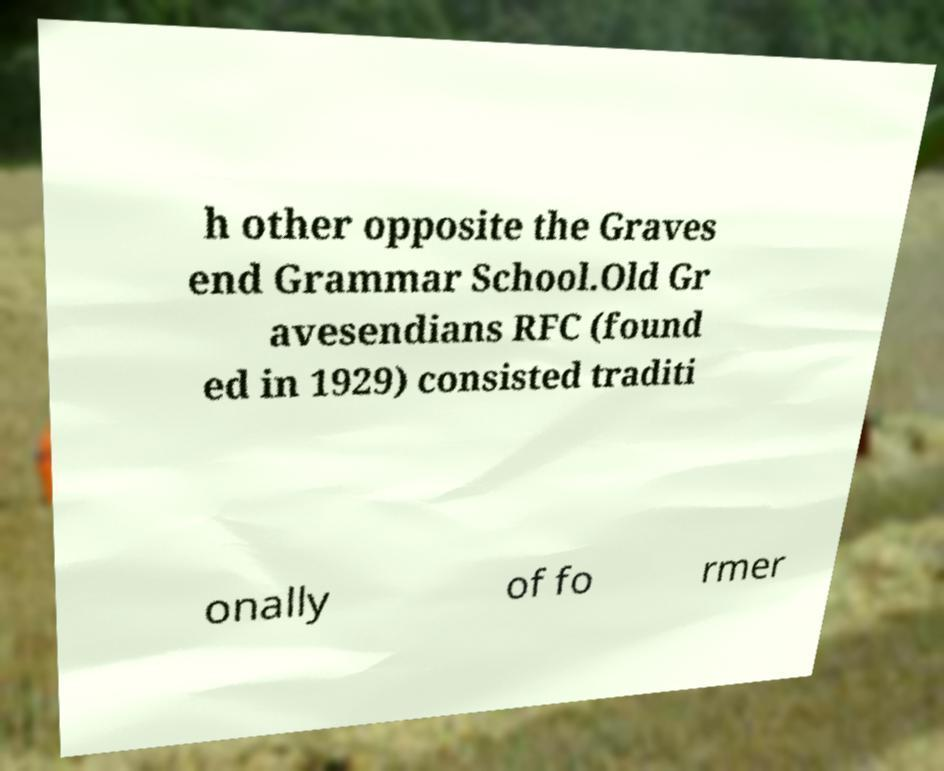Could you assist in decoding the text presented in this image and type it out clearly? h other opposite the Graves end Grammar School.Old Gr avesendians RFC (found ed in 1929) consisted traditi onally of fo rmer 